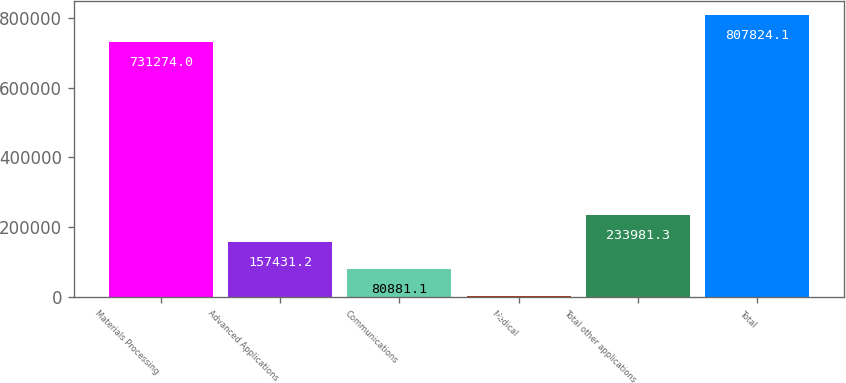Convert chart. <chart><loc_0><loc_0><loc_500><loc_500><bar_chart><fcel>Materials Processing<fcel>Advanced Applications<fcel>Communications<fcel>Medical<fcel>Total other applications<fcel>Total<nl><fcel>731274<fcel>157431<fcel>80881.1<fcel>4331<fcel>233981<fcel>807824<nl></chart> 